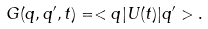Convert formula to latex. <formula><loc_0><loc_0><loc_500><loc_500>G ( q , q ^ { \prime } , t ) = < q | U ( t ) | q ^ { \prime } > .</formula> 